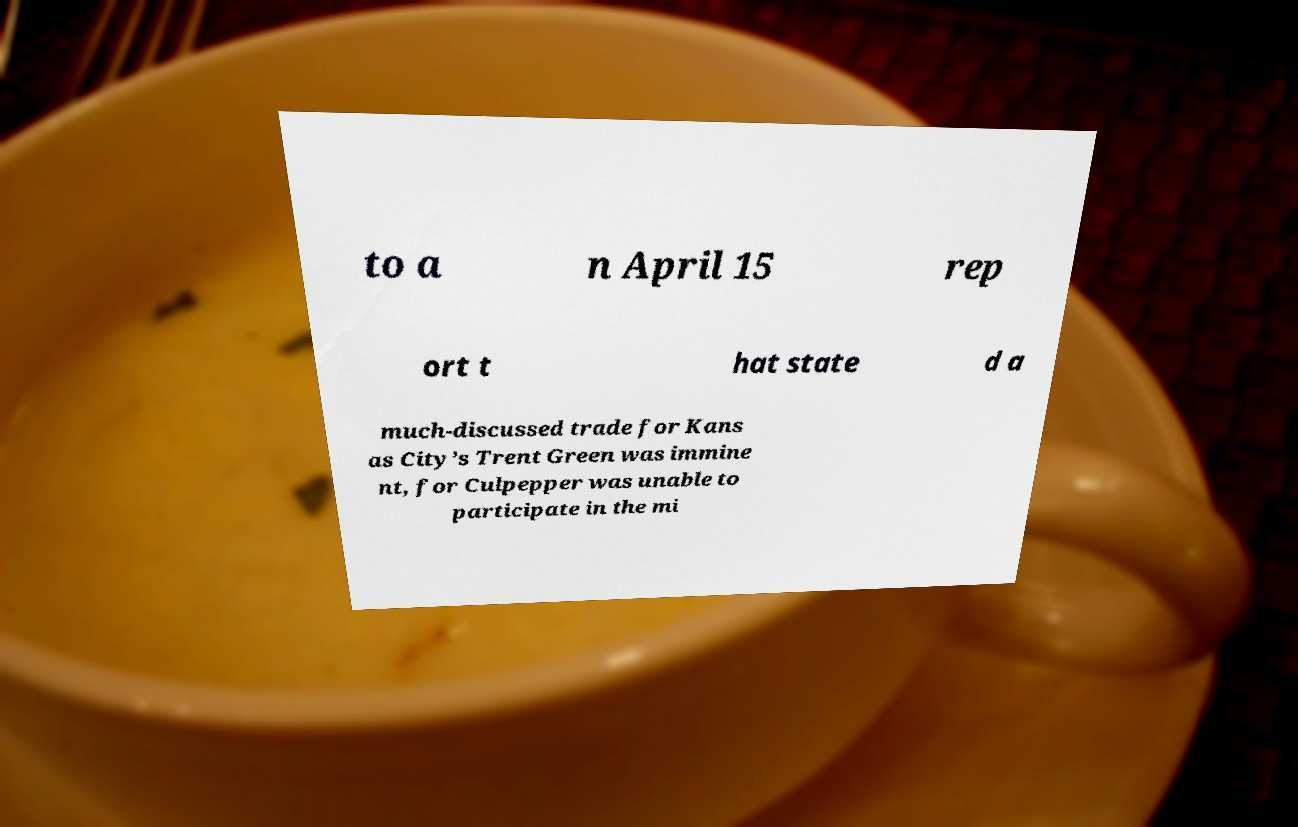What messages or text are displayed in this image? I need them in a readable, typed format. to a n April 15 rep ort t hat state d a much-discussed trade for Kans as City’s Trent Green was immine nt, for Culpepper was unable to participate in the mi 